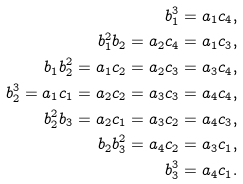<formula> <loc_0><loc_0><loc_500><loc_500>b _ { 1 } ^ { 3 } & = a _ { 1 } c _ { 4 } , \\ b _ { 1 } ^ { 2 } b _ { 2 } = a _ { 2 } c _ { 4 } & = a _ { 1 } c _ { 3 } , \\ b _ { 1 } b _ { 2 } ^ { 2 } = a _ { 1 } c _ { 2 } = a _ { 2 } c _ { 3 } & = a _ { 3 } c _ { 4 } , \\ b _ { 2 } ^ { 3 } = a _ { 1 } c _ { 1 } = a _ { 2 } c _ { 2 } = a _ { 3 } c _ { 3 } & = a _ { 4 } c _ { 4 } , \\ b _ { 2 } ^ { 2 } b _ { 3 } = a _ { 2 } c _ { 1 } = a _ { 3 } c _ { 2 } & = a _ { 4 } c _ { 3 } , \\ b _ { 2 } b _ { 3 } ^ { 2 } = a _ { 4 } c _ { 2 } & = a _ { 3 } c _ { 1 } , \\ b _ { 3 } ^ { 3 } & = a _ { 4 } c _ { 1 } .</formula> 